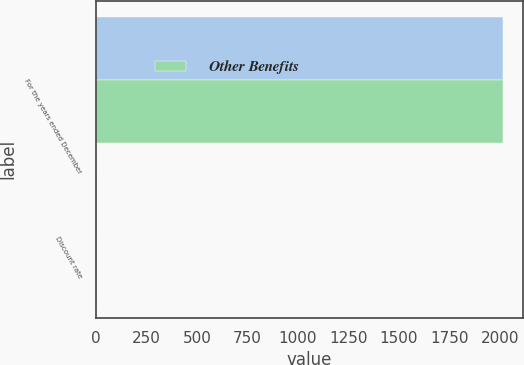<chart> <loc_0><loc_0><loc_500><loc_500><stacked_bar_chart><ecel><fcel>For the years ended December<fcel>Discount rate<nl><fcel>nan<fcel>2016<fcel>4<nl><fcel>Other Benefits<fcel>2016<fcel>4<nl></chart> 